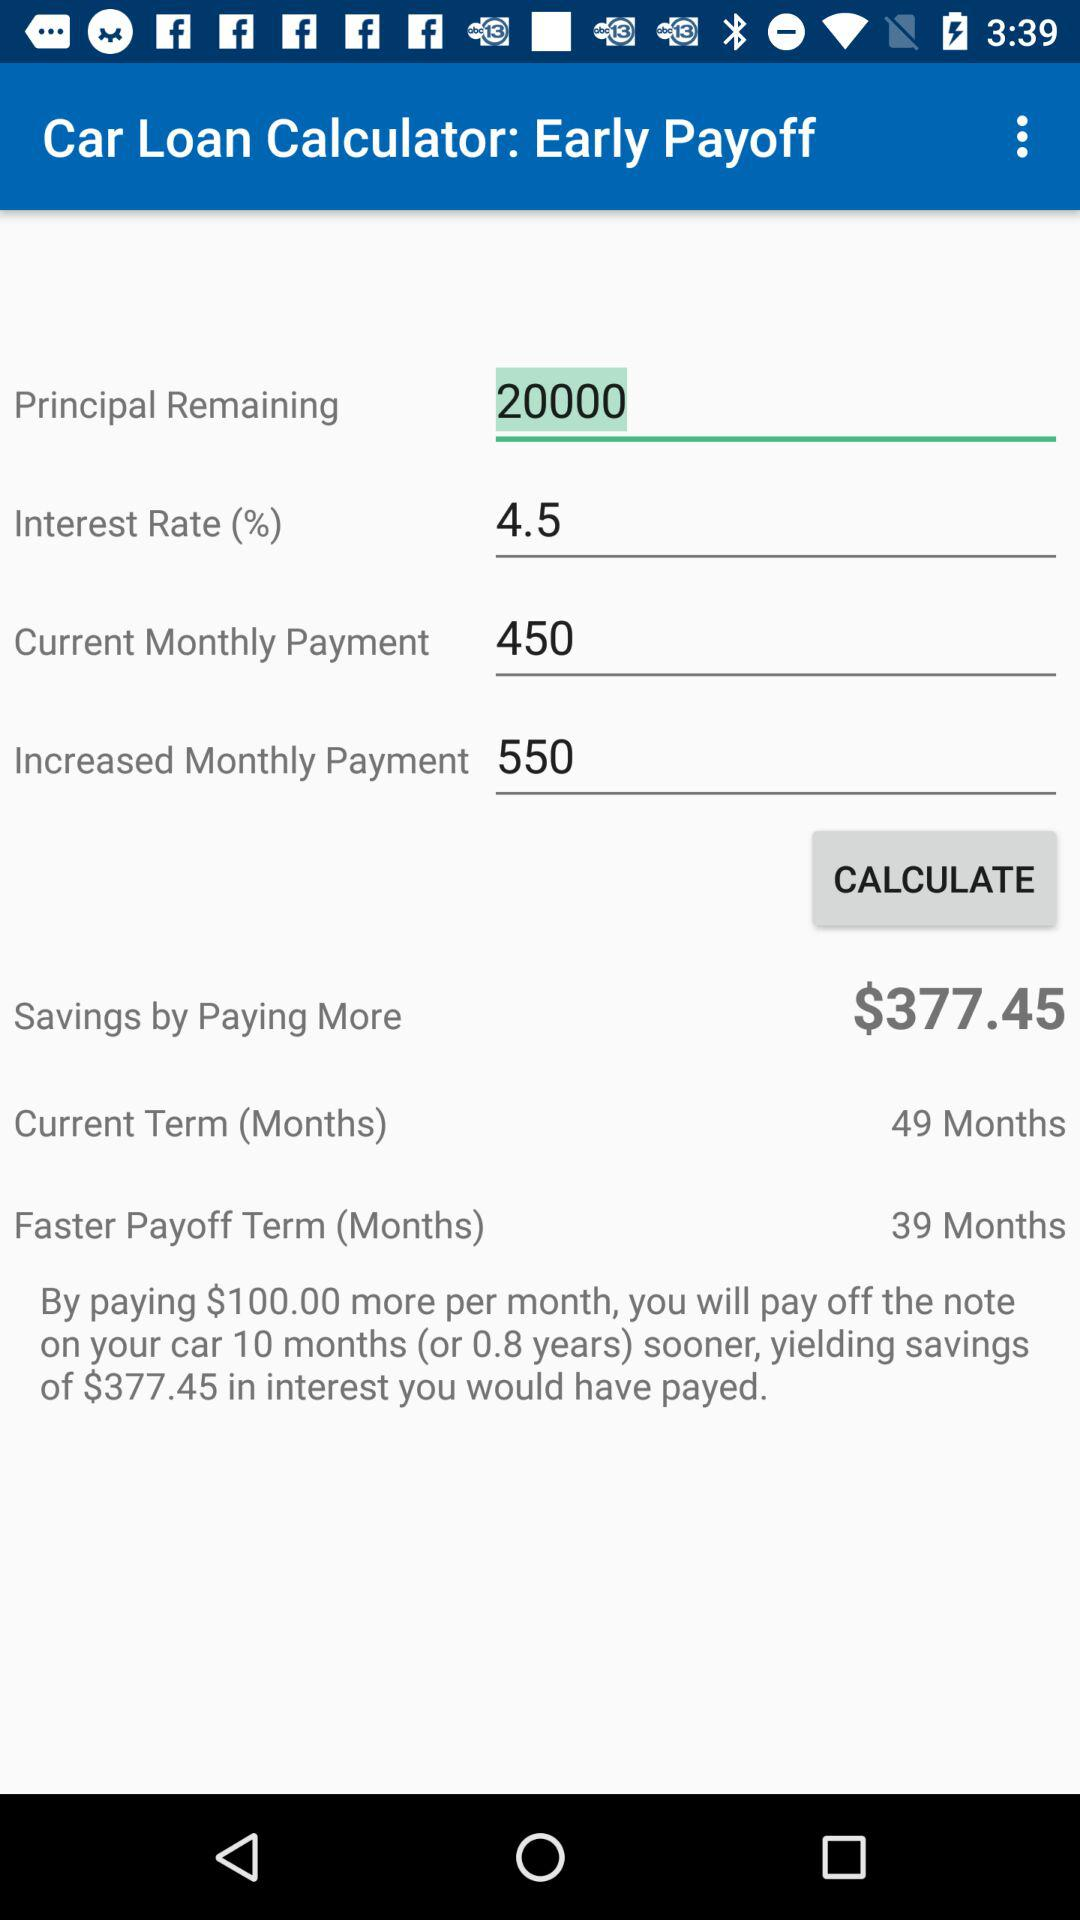How much money can be saved by paying more? By paying more, we can save $377.45. 